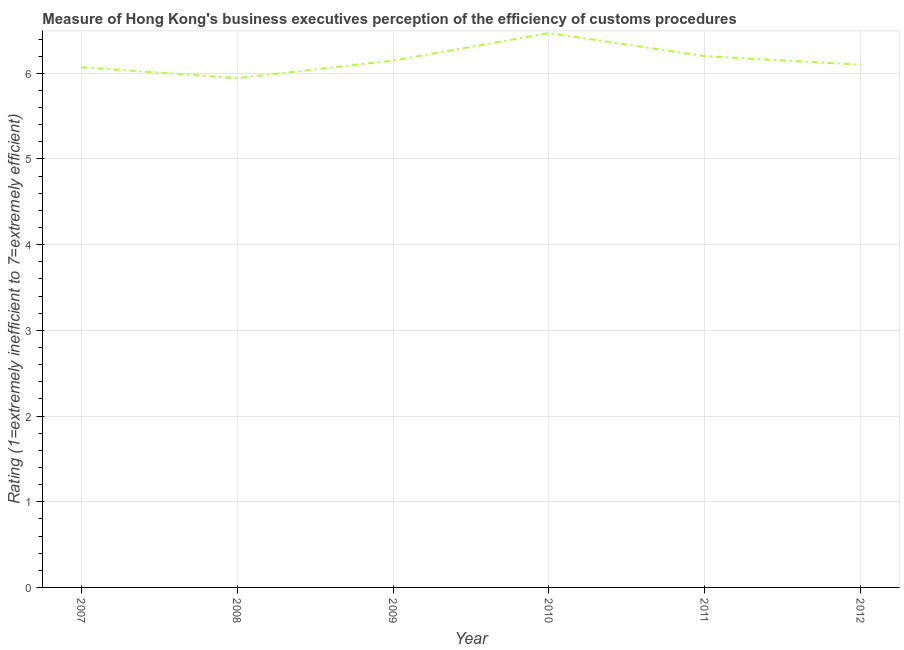Across all years, what is the maximum rating measuring burden of customs procedure?
Keep it short and to the point. 6.47. Across all years, what is the minimum rating measuring burden of customs procedure?
Your answer should be compact. 5.94. In which year was the rating measuring burden of customs procedure maximum?
Give a very brief answer. 2010. In which year was the rating measuring burden of customs procedure minimum?
Provide a short and direct response. 2008. What is the sum of the rating measuring burden of customs procedure?
Provide a short and direct response. 36.93. What is the difference between the rating measuring burden of customs procedure in 2007 and 2009?
Give a very brief answer. -0.08. What is the average rating measuring burden of customs procedure per year?
Keep it short and to the point. 6.16. What is the median rating measuring burden of customs procedure?
Provide a succinct answer. 6.12. In how many years, is the rating measuring burden of customs procedure greater than 4 ?
Offer a terse response. 6. What is the ratio of the rating measuring burden of customs procedure in 2009 to that in 2012?
Your response must be concise. 1.01. Is the rating measuring burden of customs procedure in 2010 less than that in 2011?
Provide a short and direct response. No. What is the difference between the highest and the second highest rating measuring burden of customs procedure?
Provide a short and direct response. 0.27. What is the difference between the highest and the lowest rating measuring burden of customs procedure?
Your answer should be compact. 0.53. Does the rating measuring burden of customs procedure monotonically increase over the years?
Provide a short and direct response. No. How many lines are there?
Keep it short and to the point. 1. Are the values on the major ticks of Y-axis written in scientific E-notation?
Give a very brief answer. No. Does the graph contain grids?
Provide a short and direct response. Yes. What is the title of the graph?
Offer a very short reply. Measure of Hong Kong's business executives perception of the efficiency of customs procedures. What is the label or title of the X-axis?
Offer a very short reply. Year. What is the label or title of the Y-axis?
Your response must be concise. Rating (1=extremely inefficient to 7=extremely efficient). What is the Rating (1=extremely inefficient to 7=extremely efficient) of 2007?
Your response must be concise. 6.07. What is the Rating (1=extremely inefficient to 7=extremely efficient) of 2008?
Ensure brevity in your answer.  5.94. What is the Rating (1=extremely inefficient to 7=extremely efficient) of 2009?
Offer a terse response. 6.15. What is the Rating (1=extremely inefficient to 7=extremely efficient) in 2010?
Offer a very short reply. 6.47. What is the Rating (1=extremely inefficient to 7=extremely efficient) in 2011?
Ensure brevity in your answer.  6.2. What is the Rating (1=extremely inefficient to 7=extremely efficient) of 2012?
Provide a short and direct response. 6.1. What is the difference between the Rating (1=extremely inefficient to 7=extremely efficient) in 2007 and 2008?
Provide a succinct answer. 0.13. What is the difference between the Rating (1=extremely inefficient to 7=extremely efficient) in 2007 and 2009?
Offer a very short reply. -0.08. What is the difference between the Rating (1=extremely inefficient to 7=extremely efficient) in 2007 and 2010?
Make the answer very short. -0.4. What is the difference between the Rating (1=extremely inefficient to 7=extremely efficient) in 2007 and 2011?
Provide a succinct answer. -0.13. What is the difference between the Rating (1=extremely inefficient to 7=extremely efficient) in 2007 and 2012?
Give a very brief answer. -0.03. What is the difference between the Rating (1=extremely inefficient to 7=extremely efficient) in 2008 and 2009?
Your response must be concise. -0.2. What is the difference between the Rating (1=extremely inefficient to 7=extremely efficient) in 2008 and 2010?
Make the answer very short. -0.53. What is the difference between the Rating (1=extremely inefficient to 7=extremely efficient) in 2008 and 2011?
Offer a very short reply. -0.26. What is the difference between the Rating (1=extremely inefficient to 7=extremely efficient) in 2008 and 2012?
Give a very brief answer. -0.16. What is the difference between the Rating (1=extremely inefficient to 7=extremely efficient) in 2009 and 2010?
Your answer should be compact. -0.32. What is the difference between the Rating (1=extremely inefficient to 7=extremely efficient) in 2009 and 2011?
Provide a short and direct response. -0.05. What is the difference between the Rating (1=extremely inefficient to 7=extremely efficient) in 2009 and 2012?
Provide a succinct answer. 0.05. What is the difference between the Rating (1=extremely inefficient to 7=extremely efficient) in 2010 and 2011?
Your answer should be very brief. 0.27. What is the difference between the Rating (1=extremely inefficient to 7=extremely efficient) in 2010 and 2012?
Offer a very short reply. 0.37. What is the difference between the Rating (1=extremely inefficient to 7=extremely efficient) in 2011 and 2012?
Make the answer very short. 0.1. What is the ratio of the Rating (1=extremely inefficient to 7=extremely efficient) in 2007 to that in 2008?
Give a very brief answer. 1.02. What is the ratio of the Rating (1=extremely inefficient to 7=extremely efficient) in 2007 to that in 2010?
Your answer should be compact. 0.94. What is the ratio of the Rating (1=extremely inefficient to 7=extremely efficient) in 2008 to that in 2010?
Give a very brief answer. 0.92. What is the ratio of the Rating (1=extremely inefficient to 7=extremely efficient) in 2008 to that in 2011?
Make the answer very short. 0.96. What is the ratio of the Rating (1=extremely inefficient to 7=extremely efficient) in 2009 to that in 2010?
Keep it short and to the point. 0.95. What is the ratio of the Rating (1=extremely inefficient to 7=extremely efficient) in 2009 to that in 2011?
Your answer should be very brief. 0.99. What is the ratio of the Rating (1=extremely inefficient to 7=extremely efficient) in 2009 to that in 2012?
Ensure brevity in your answer.  1.01. What is the ratio of the Rating (1=extremely inefficient to 7=extremely efficient) in 2010 to that in 2011?
Make the answer very short. 1.04. What is the ratio of the Rating (1=extremely inefficient to 7=extremely efficient) in 2010 to that in 2012?
Keep it short and to the point. 1.06. What is the ratio of the Rating (1=extremely inefficient to 7=extremely efficient) in 2011 to that in 2012?
Provide a short and direct response. 1.02. 